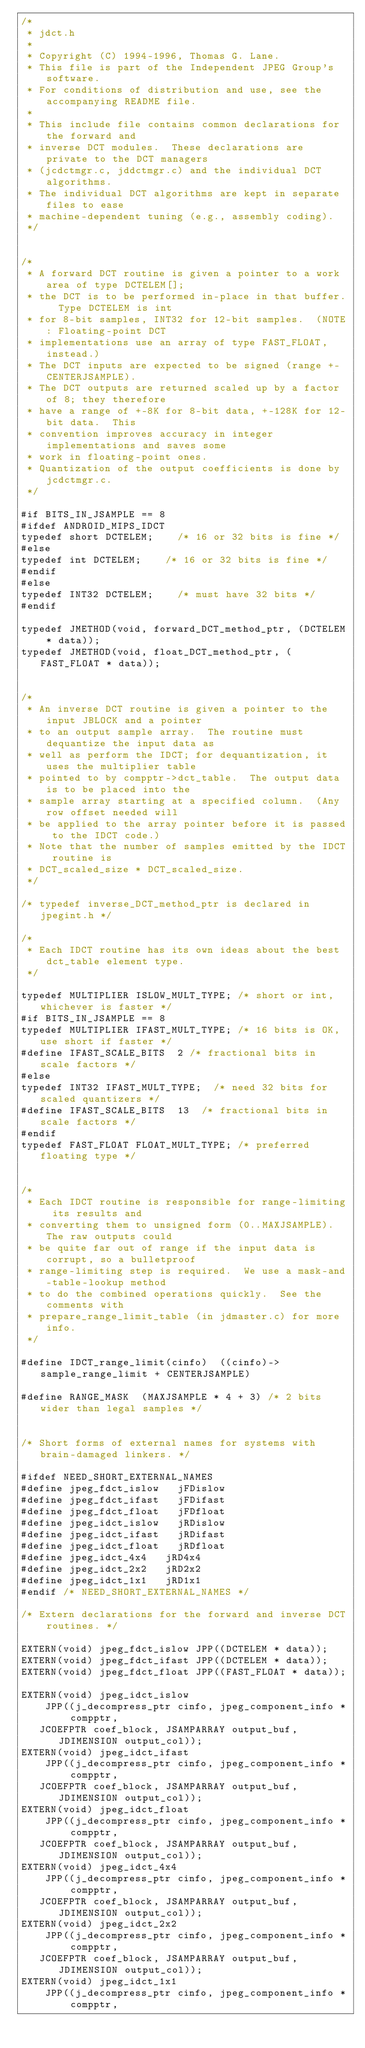<code> <loc_0><loc_0><loc_500><loc_500><_C_>/*
 * jdct.h
 *
 * Copyright (C) 1994-1996, Thomas G. Lane.
 * This file is part of the Independent JPEG Group's software.
 * For conditions of distribution and use, see the accompanying README file.
 *
 * This include file contains common declarations for the forward and
 * inverse DCT modules.  These declarations are private to the DCT managers
 * (jcdctmgr.c, jddctmgr.c) and the individual DCT algorithms.
 * The individual DCT algorithms are kept in separate files to ease 
 * machine-dependent tuning (e.g., assembly coding).
 */


/*
 * A forward DCT routine is given a pointer to a work area of type DCTELEM[];
 * the DCT is to be performed in-place in that buffer.  Type DCTELEM is int
 * for 8-bit samples, INT32 for 12-bit samples.  (NOTE: Floating-point DCT
 * implementations use an array of type FAST_FLOAT, instead.)
 * The DCT inputs are expected to be signed (range +-CENTERJSAMPLE).
 * The DCT outputs are returned scaled up by a factor of 8; they therefore
 * have a range of +-8K for 8-bit data, +-128K for 12-bit data.  This
 * convention improves accuracy in integer implementations and saves some
 * work in floating-point ones.
 * Quantization of the output coefficients is done by jcdctmgr.c.
 */

#if BITS_IN_JSAMPLE == 8
#ifdef ANDROID_MIPS_IDCT
typedef short DCTELEM;		/* 16 or 32 bits is fine */
#else
typedef int DCTELEM;		/* 16 or 32 bits is fine */
#endif
#else
typedef INT32 DCTELEM;		/* must have 32 bits */
#endif

typedef JMETHOD(void, forward_DCT_method_ptr, (DCTELEM * data));
typedef JMETHOD(void, float_DCT_method_ptr, (FAST_FLOAT * data));


/*
 * An inverse DCT routine is given a pointer to the input JBLOCK and a pointer
 * to an output sample array.  The routine must dequantize the input data as
 * well as perform the IDCT; for dequantization, it uses the multiplier table
 * pointed to by compptr->dct_table.  The output data is to be placed into the
 * sample array starting at a specified column.  (Any row offset needed will
 * be applied to the array pointer before it is passed to the IDCT code.)
 * Note that the number of samples emitted by the IDCT routine is
 * DCT_scaled_size * DCT_scaled_size.
 */

/* typedef inverse_DCT_method_ptr is declared in jpegint.h */

/*
 * Each IDCT routine has its own ideas about the best dct_table element type.
 */

typedef MULTIPLIER ISLOW_MULT_TYPE; /* short or int, whichever is faster */
#if BITS_IN_JSAMPLE == 8
typedef MULTIPLIER IFAST_MULT_TYPE; /* 16 bits is OK, use short if faster */
#define IFAST_SCALE_BITS  2	/* fractional bits in scale factors */
#else
typedef INT32 IFAST_MULT_TYPE;	/* need 32 bits for scaled quantizers */
#define IFAST_SCALE_BITS  13	/* fractional bits in scale factors */
#endif
typedef FAST_FLOAT FLOAT_MULT_TYPE; /* preferred floating type */


/*
 * Each IDCT routine is responsible for range-limiting its results and
 * converting them to unsigned form (0..MAXJSAMPLE).  The raw outputs could
 * be quite far out of range if the input data is corrupt, so a bulletproof
 * range-limiting step is required.  We use a mask-and-table-lookup method
 * to do the combined operations quickly.  See the comments with
 * prepare_range_limit_table (in jdmaster.c) for more info.
 */

#define IDCT_range_limit(cinfo)  ((cinfo)->sample_range_limit + CENTERJSAMPLE)

#define RANGE_MASK  (MAXJSAMPLE * 4 + 3) /* 2 bits wider than legal samples */


/* Short forms of external names for systems with brain-damaged linkers. */

#ifdef NEED_SHORT_EXTERNAL_NAMES
#define jpeg_fdct_islow		jFDislow
#define jpeg_fdct_ifast		jFDifast
#define jpeg_fdct_float		jFDfloat
#define jpeg_idct_islow		jRDislow
#define jpeg_idct_ifast		jRDifast
#define jpeg_idct_float		jRDfloat
#define jpeg_idct_4x4		jRD4x4
#define jpeg_idct_2x2		jRD2x2
#define jpeg_idct_1x1		jRD1x1
#endif /* NEED_SHORT_EXTERNAL_NAMES */

/* Extern declarations for the forward and inverse DCT routines. */

EXTERN(void) jpeg_fdct_islow JPP((DCTELEM * data));
EXTERN(void) jpeg_fdct_ifast JPP((DCTELEM * data));
EXTERN(void) jpeg_fdct_float JPP((FAST_FLOAT * data));

EXTERN(void) jpeg_idct_islow
    JPP((j_decompress_ptr cinfo, jpeg_component_info * compptr,
	 JCOEFPTR coef_block, JSAMPARRAY output_buf, JDIMENSION output_col));
EXTERN(void) jpeg_idct_ifast
    JPP((j_decompress_ptr cinfo, jpeg_component_info * compptr,
	 JCOEFPTR coef_block, JSAMPARRAY output_buf, JDIMENSION output_col));
EXTERN(void) jpeg_idct_float
    JPP((j_decompress_ptr cinfo, jpeg_component_info * compptr,
	 JCOEFPTR coef_block, JSAMPARRAY output_buf, JDIMENSION output_col));
EXTERN(void) jpeg_idct_4x4
    JPP((j_decompress_ptr cinfo, jpeg_component_info * compptr,
	 JCOEFPTR coef_block, JSAMPARRAY output_buf, JDIMENSION output_col));
EXTERN(void) jpeg_idct_2x2
    JPP((j_decompress_ptr cinfo, jpeg_component_info * compptr,
	 JCOEFPTR coef_block, JSAMPARRAY output_buf, JDIMENSION output_col));
EXTERN(void) jpeg_idct_1x1
    JPP((j_decompress_ptr cinfo, jpeg_component_info * compptr,</code> 